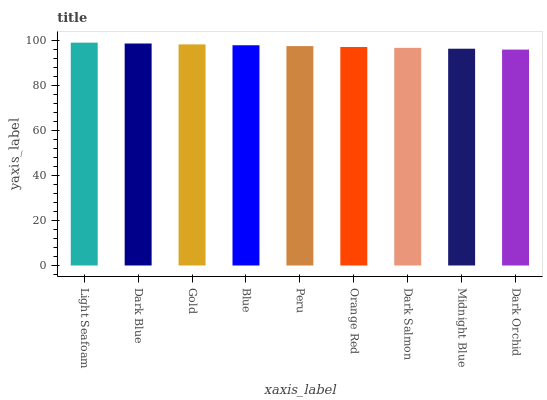Is Dark Orchid the minimum?
Answer yes or no. Yes. Is Light Seafoam the maximum?
Answer yes or no. Yes. Is Dark Blue the minimum?
Answer yes or no. No. Is Dark Blue the maximum?
Answer yes or no. No. Is Light Seafoam greater than Dark Blue?
Answer yes or no. Yes. Is Dark Blue less than Light Seafoam?
Answer yes or no. Yes. Is Dark Blue greater than Light Seafoam?
Answer yes or no. No. Is Light Seafoam less than Dark Blue?
Answer yes or no. No. Is Peru the high median?
Answer yes or no. Yes. Is Peru the low median?
Answer yes or no. Yes. Is Gold the high median?
Answer yes or no. No. Is Gold the low median?
Answer yes or no. No. 